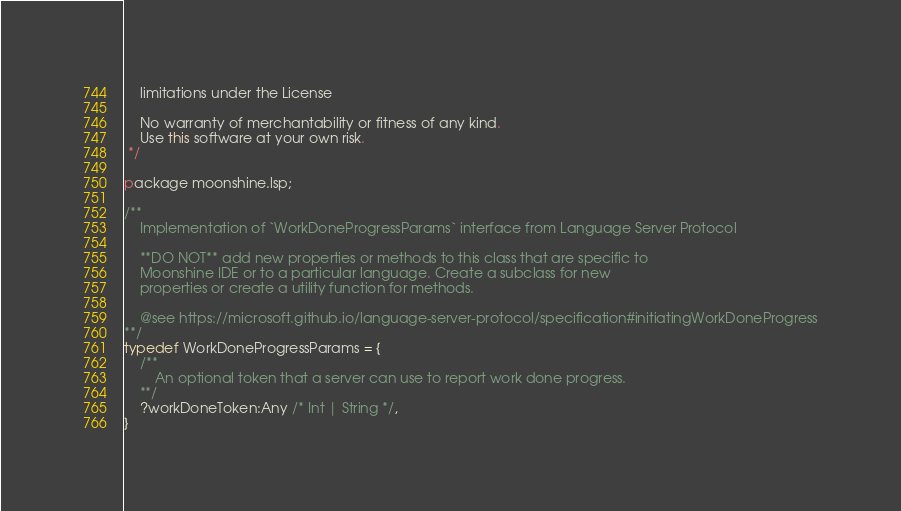Convert code to text. <code><loc_0><loc_0><loc_500><loc_500><_Haxe_>	limitations under the License

	No warranty of merchantability or fitness of any kind.
	Use this software at your own risk.
 */

package moonshine.lsp;

/**
	Implementation of `WorkDoneProgressParams` interface from Language Server Protocol

	**DO NOT** add new properties or methods to this class that are specific to
	Moonshine IDE or to a particular language. Create a subclass for new
	properties or create a utility function for methods.
	 
	@see https://microsoft.github.io/language-server-protocol/specification#initiatingWorkDoneProgress
**/
typedef WorkDoneProgressParams = {
	/**
		An optional token that a server can use to report work done progress.
	**/
	?workDoneToken:Any /* Int | String */,
}
</code> 